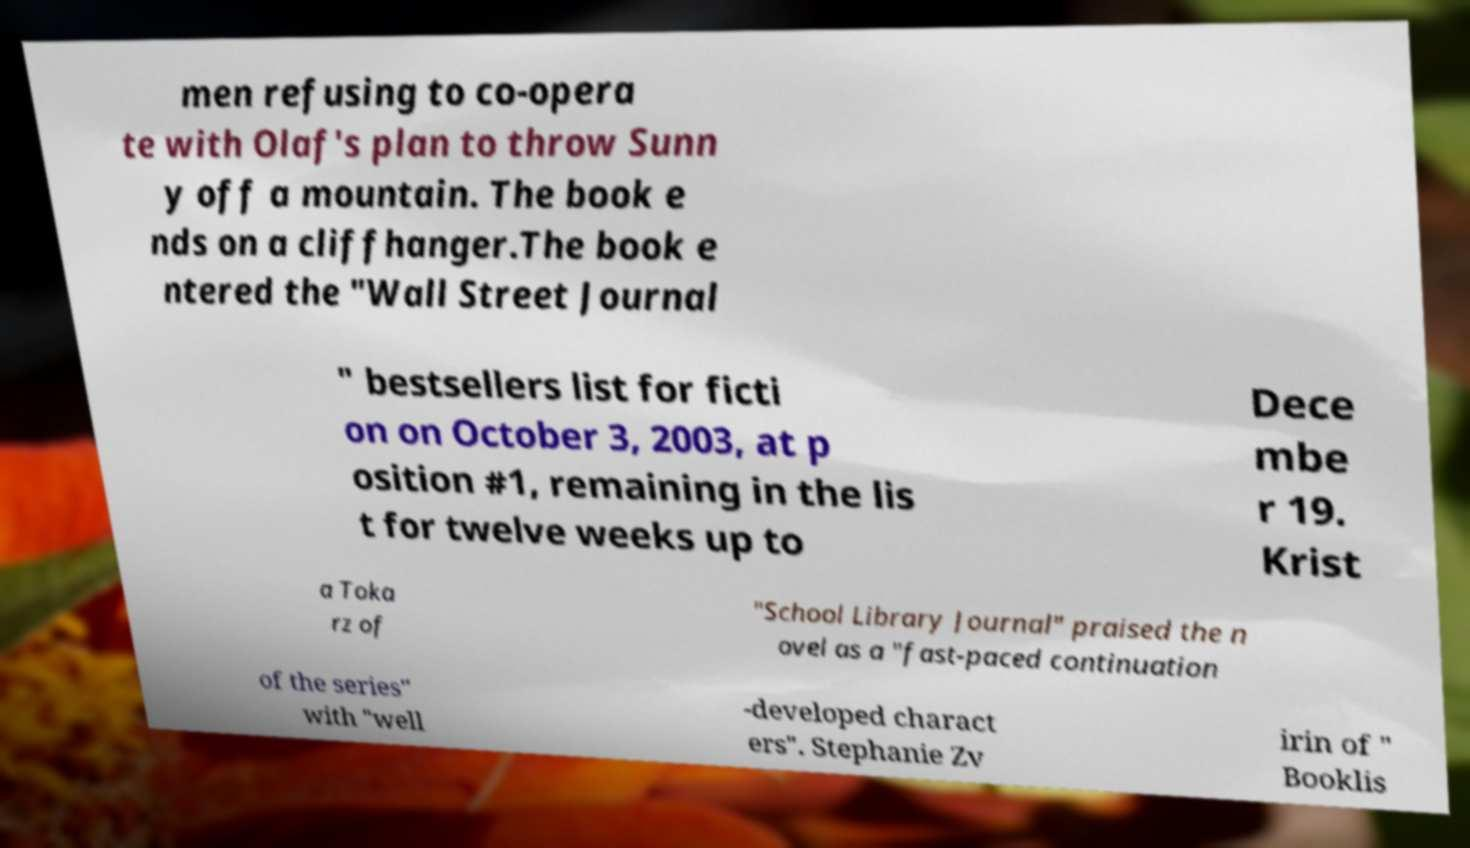Please read and relay the text visible in this image. What does it say? men refusing to co-opera te with Olaf's plan to throw Sunn y off a mountain. The book e nds on a cliffhanger.The book e ntered the "Wall Street Journal " bestsellers list for ficti on on October 3, 2003, at p osition #1, remaining in the lis t for twelve weeks up to Dece mbe r 19. Krist a Toka rz of "School Library Journal" praised the n ovel as a "fast-paced continuation of the series" with "well -developed charact ers". Stephanie Zv irin of " Booklis 